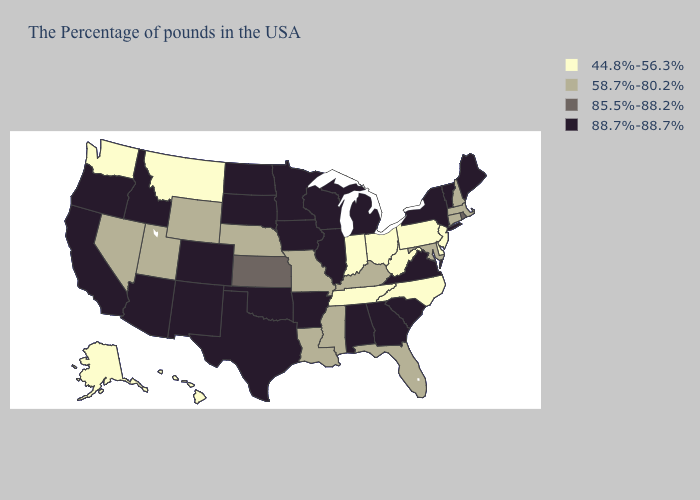Among the states that border Arkansas , does Tennessee have the highest value?
Write a very short answer. No. Among the states that border Massachusetts , which have the lowest value?
Write a very short answer. New Hampshire, Connecticut. Name the states that have a value in the range 88.7%-88.7%?
Write a very short answer. Maine, Vermont, New York, Virginia, South Carolina, Georgia, Michigan, Alabama, Wisconsin, Illinois, Arkansas, Minnesota, Iowa, Oklahoma, Texas, South Dakota, North Dakota, Colorado, New Mexico, Arizona, Idaho, California, Oregon. Name the states that have a value in the range 44.8%-56.3%?
Answer briefly. New Jersey, Delaware, Pennsylvania, North Carolina, West Virginia, Ohio, Indiana, Tennessee, Montana, Washington, Alaska, Hawaii. Name the states that have a value in the range 88.7%-88.7%?
Write a very short answer. Maine, Vermont, New York, Virginia, South Carolina, Georgia, Michigan, Alabama, Wisconsin, Illinois, Arkansas, Minnesota, Iowa, Oklahoma, Texas, South Dakota, North Dakota, Colorado, New Mexico, Arizona, Idaho, California, Oregon. Does the map have missing data?
Concise answer only. No. Does Nevada have the same value as Nebraska?
Quick response, please. Yes. What is the lowest value in the West?
Keep it brief. 44.8%-56.3%. Name the states that have a value in the range 58.7%-80.2%?
Short answer required. Massachusetts, New Hampshire, Connecticut, Maryland, Florida, Kentucky, Mississippi, Louisiana, Missouri, Nebraska, Wyoming, Utah, Nevada. Does the map have missing data?
Short answer required. No. Does Missouri have a higher value than Indiana?
Quick response, please. Yes. Name the states that have a value in the range 58.7%-80.2%?
Concise answer only. Massachusetts, New Hampshire, Connecticut, Maryland, Florida, Kentucky, Mississippi, Louisiana, Missouri, Nebraska, Wyoming, Utah, Nevada. Does Washington have the lowest value in the USA?
Quick response, please. Yes. Among the states that border Delaware , does Pennsylvania have the lowest value?
Answer briefly. Yes. Name the states that have a value in the range 44.8%-56.3%?
Concise answer only. New Jersey, Delaware, Pennsylvania, North Carolina, West Virginia, Ohio, Indiana, Tennessee, Montana, Washington, Alaska, Hawaii. 